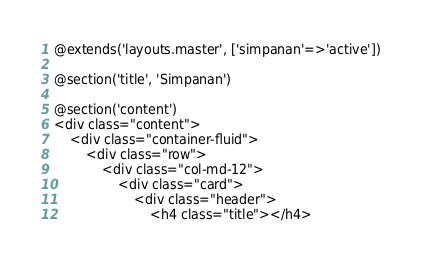Convert code to text. <code><loc_0><loc_0><loc_500><loc_500><_PHP_>@extends('layouts.master', ['simpanan'=>'active'])

@section('title', 'Simpanan')

@section('content')
<div class="content">
    <div class="container-fluid">
        <div class="row">
            <div class="col-md-12">
                <div class="card">
                    <div class="header">
                        <h4 class="title"></h4></code> 